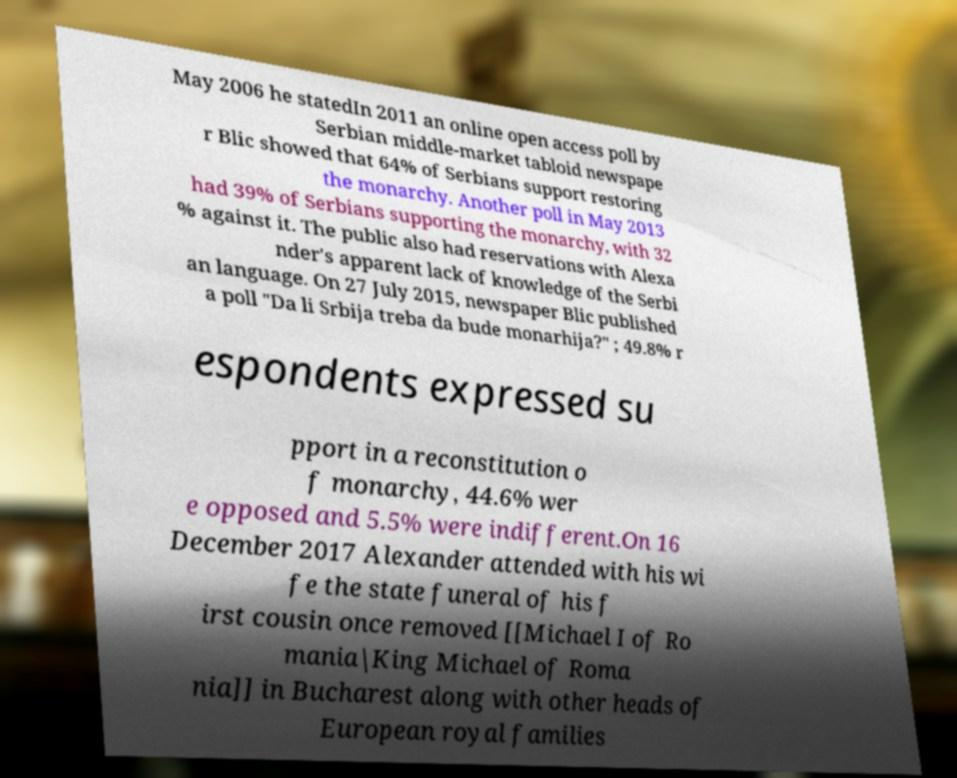Please read and relay the text visible in this image. What does it say? May 2006 he statedIn 2011 an online open access poll by Serbian middle-market tabloid newspape r Blic showed that 64% of Serbians support restoring the monarchy. Another poll in May 2013 had 39% of Serbians supporting the monarchy, with 32 % against it. The public also had reservations with Alexa nder's apparent lack of knowledge of the Serbi an language. On 27 July 2015, newspaper Blic published a poll "Da li Srbija treba da bude monarhija?" ; 49.8% r espondents expressed su pport in a reconstitution o f monarchy, 44.6% wer e opposed and 5.5% were indifferent.On 16 December 2017 Alexander attended with his wi fe the state funeral of his f irst cousin once removed [[Michael I of Ro mania|King Michael of Roma nia]] in Bucharest along with other heads of European royal families 